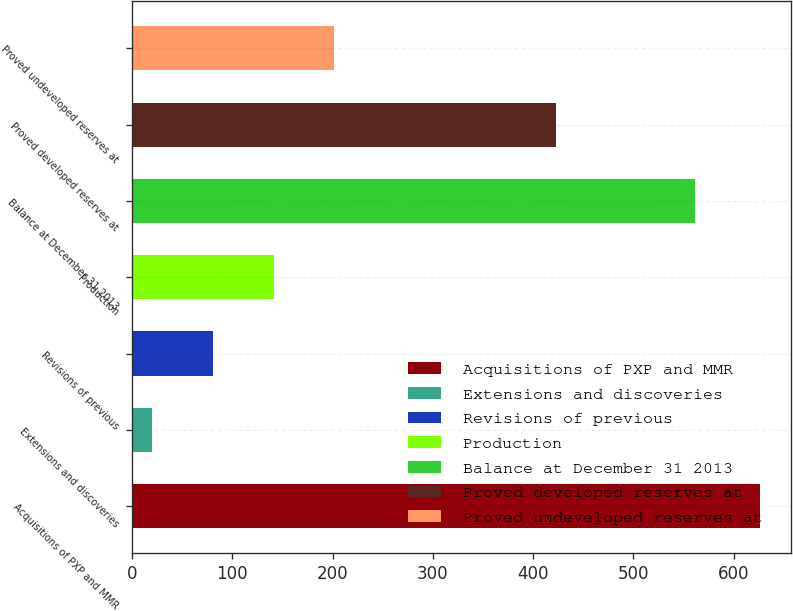Convert chart to OTSL. <chart><loc_0><loc_0><loc_500><loc_500><bar_chart><fcel>Acquisitions of PXP and MMR<fcel>Extensions and discoveries<fcel>Revisions of previous<fcel>Production<fcel>Balance at December 31 2013<fcel>Proved developed reserves at<fcel>Proved undeveloped reserves at<nl><fcel>626<fcel>20<fcel>80.6<fcel>141.2<fcel>562<fcel>423<fcel>201.8<nl></chart> 